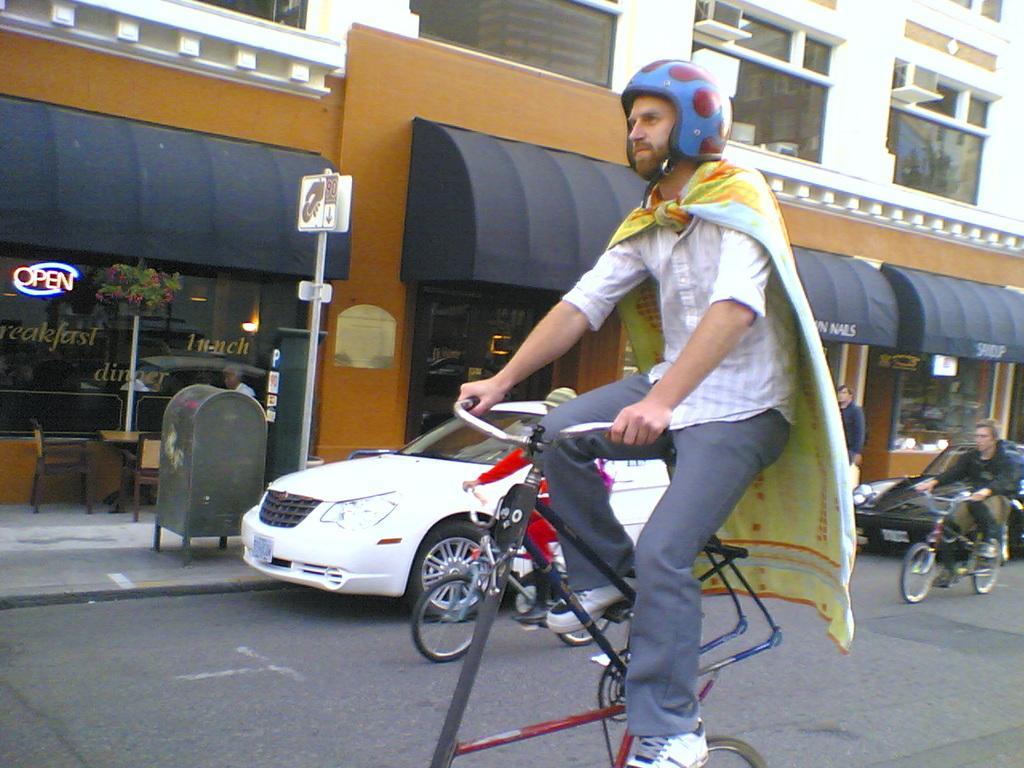Describe this image in one or two sentences. In this picture we can see a man wearing helmet and a towel on his shoulders and riding a vehicle. Near to the store and buildings we can see vehicles. This is a trash can, board over a pole. Here we can see chair and table near to the store. This is a flower plant. 